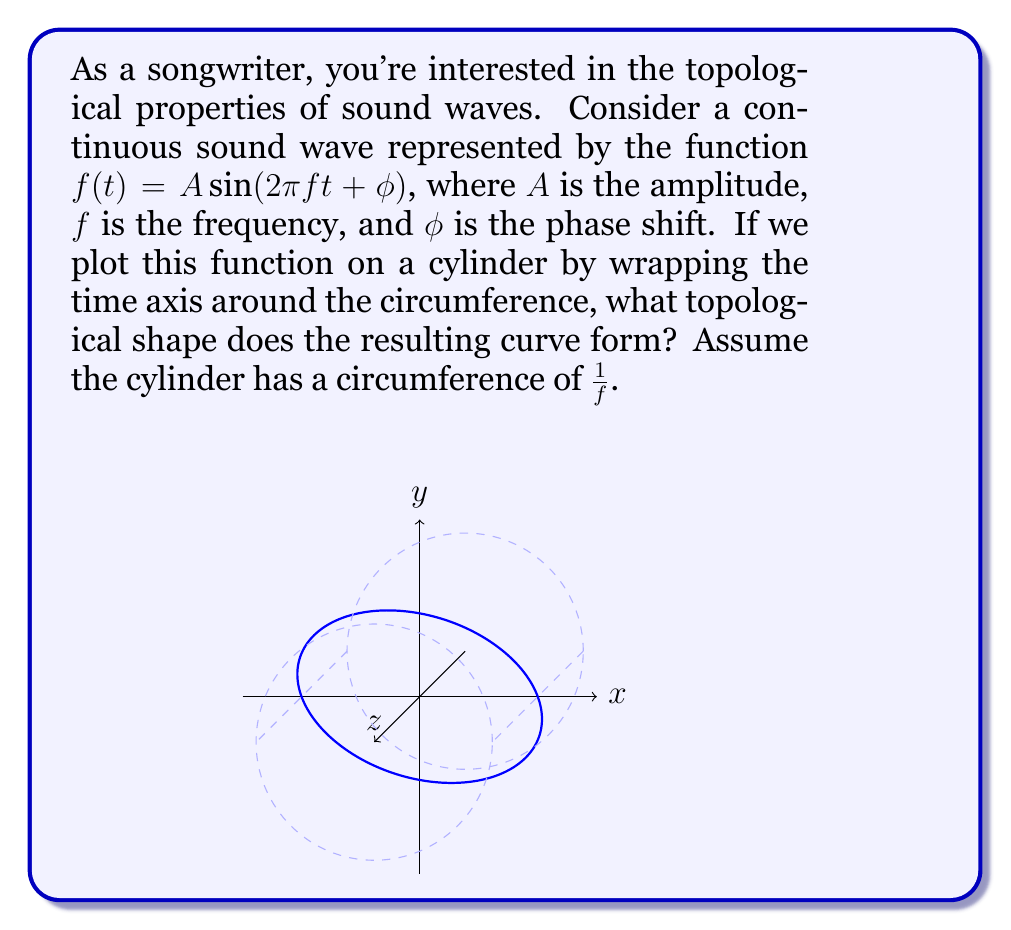Teach me how to tackle this problem. Let's approach this step-by-step:

1) The function $f(t) = A \sin(2\pi ft + \phi)$ represents a sinusoidal wave.

2) When we wrap this function around a cylinder, we're essentially creating a parametric equation:
   $x = \cos(2\pi ft)$
   $y = \sin(2\pi ft)$
   $z = A \sin(2\pi ft + \phi)$

3) The cylinder's circumference is $\frac{1}{f}$, which means one complete revolution around the cylinder corresponds to one period of the sine wave.

4) As $t$ increases, the point $(x,y,z)$ traces a path that:
   - Circles around the cylinder (due to $x$ and $y$ equations)
   - Moves up and down sinusoidally (due to $z$ equation)

5) This creates a curve that wraps around the cylinder, completing one full revolution vertically for each revolution horizontally.

6) Such a curve, which wraps around a cylinder while also moving along its axis, is known topologically as a helix.

7) Since the function is continuous and periodic, this helix will connect with itself after one complete revolution around the cylinder, forming a closed loop.

8) A closed loop on the surface of a cylinder that wraps around both the circumference and the length of the cylinder once is topologically equivalent to a torus knot of type (1,1), also known as the unknot.
Answer: Unknot (topologically equivalent to a circle) 